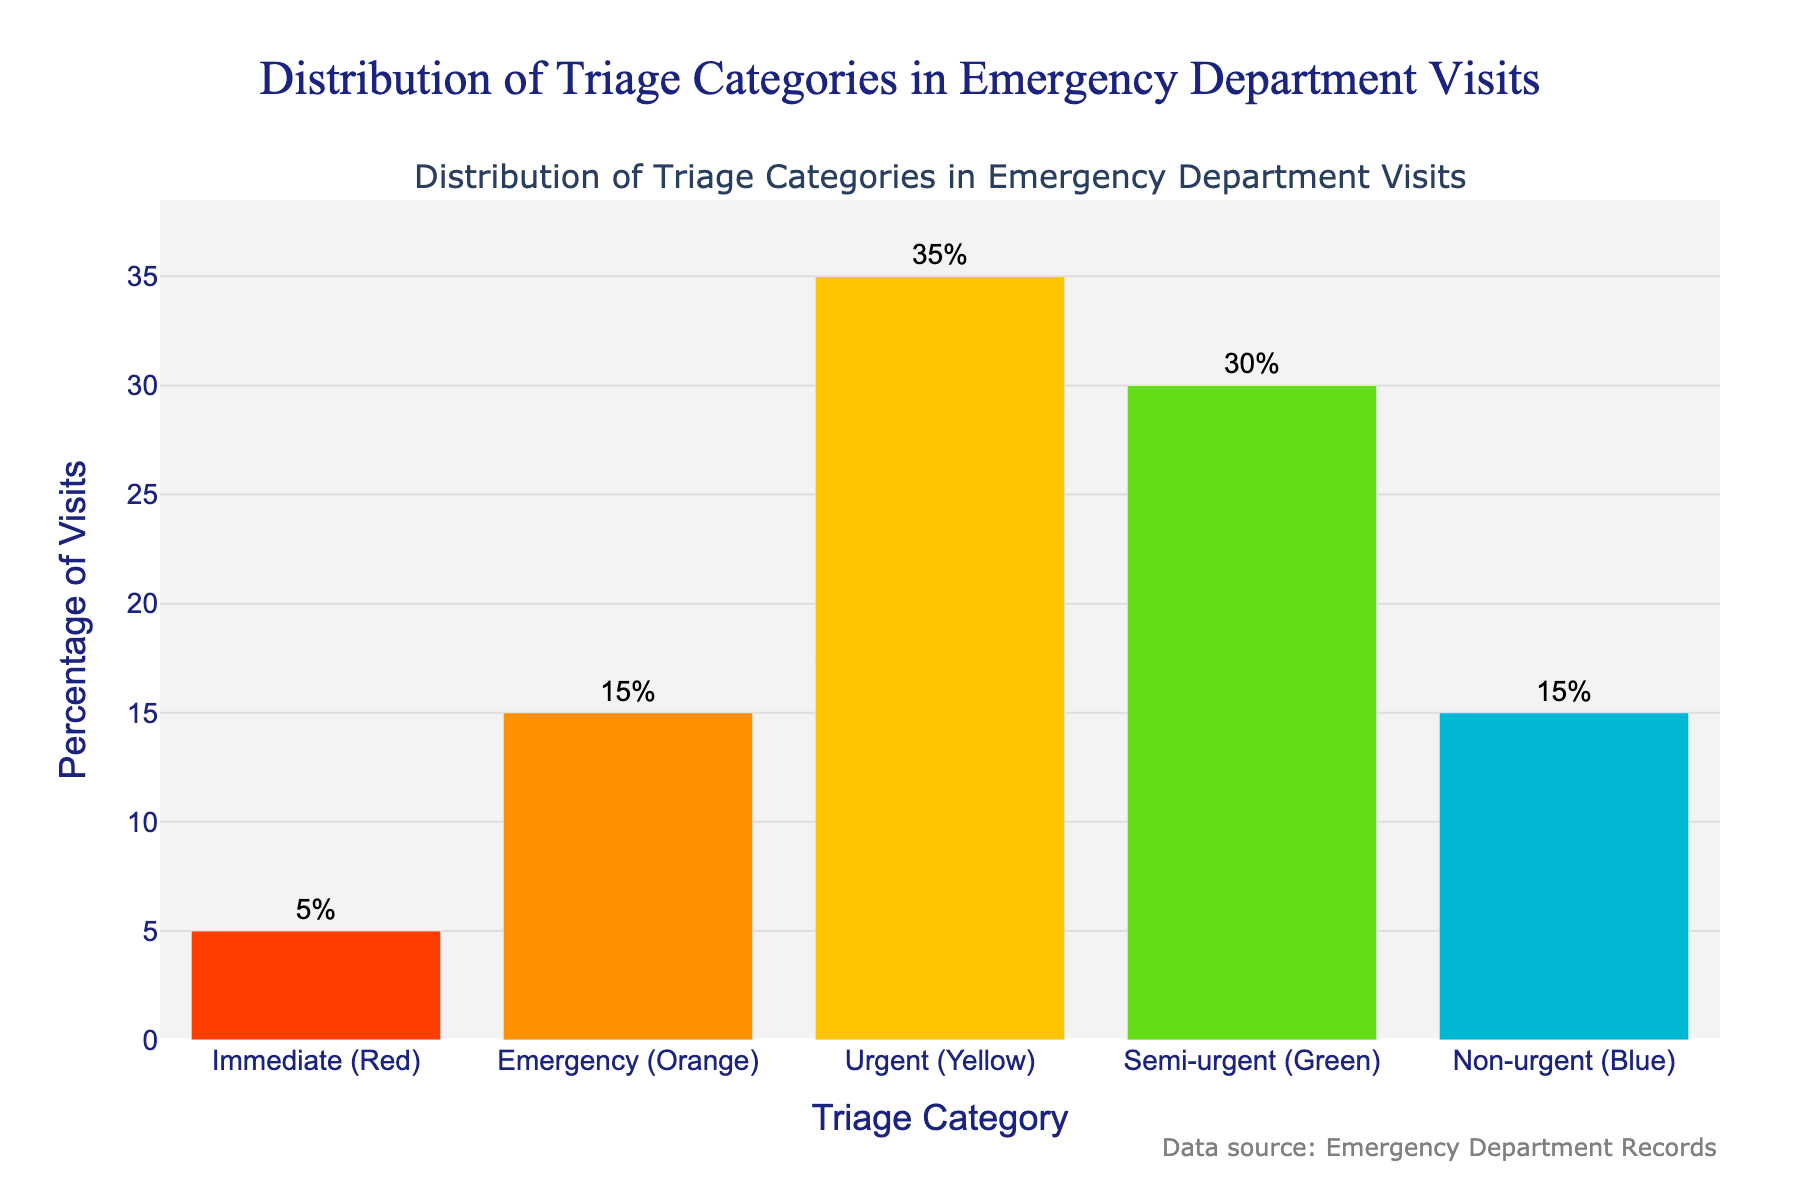What percentage of visits fall under the "Urgent (Yellow)" category? The figure shows the "Urgent (Yellow)" category percentage visually and through marked text outside the bar. The percentage labeled for the yellow bar is 35%.
Answer: 35% Which triage category has the highest percentage of visits? By comparing the height of the bars, the "Urgent (Yellow)" category is the tallest, which indicates it has the highest percentage of visits.
Answer: Urgent (Yellow) How does the percentage of "Semi-urgent (Green)" visits compare to "Non-urgent (Blue)" visits? The figure shows "Semi-urgent (Green)" with a 30% visit rate, and "Non-urgent (Blue)" with a 15% visit rate. The green bar is taller than the blue bar, indicating that "Semi-urgent (Green)" has a higher percentage.
Answer: Semi-urgent (Green) > Non-urgent (Blue) What is the combined percentage of visits in the "Emergency (Orange)" and "Immediate (Red)" categories? The figure indicates that "Emergency (Orange)" is 15% and "Immediate (Red)" is 5%. Adding these percentages together gives 15% + 5% = 20%.
Answer: 20% What percentage of visits are either "Semi-urgent (Green)" or "Non-urgent (Blue)"? The "Semi-urgent (Green)" category is 30% and the "Non-urgent (Blue)" category is 15%. Adding these together, 30% + 15% = 45%.
Answer: 45% Which color represents the category with the lowest percentage of visits? By observing the height of the bars, the "Immediate (Red)" category is the shortest, showing the lowest percentage of visits.
Answer: Red What is the difference in the percentage of visits between the highest and lowest categories? The highest category "Urgent (Yellow)" is 35%, and the lowest "Immediate (Red)" is 5%. The difference is 35% - 5% = 30%.
Answer: 30% Are there any categories with an equal percentage of visits? If yes, which ones? The "Emergency (Orange)" and "Non-urgent (Blue)" categories both show a percentage of 15%.
Answer: Yes, Emergency (Orange) and Non-urgent (Blue) What is the average percentage of visits across all categories? The percentages for each category are 5%, 15%, 35%, 30%, and 15%. Summing these values gives 5 + 15 + 35 + 30 + 15 = 100. Dividing by the number of categories (5) gives an average of 100 / 5 = 20%.
Answer: 20% How much higher is the percentage of "Urgent (Yellow)" visits compared to "Emergency (Orange)" visits? The "Urgent (Yellow)" category is 35% and the "Emergency (Orange)" category is 15%. The difference is 35% - 15% = 20%.
Answer: 20% 